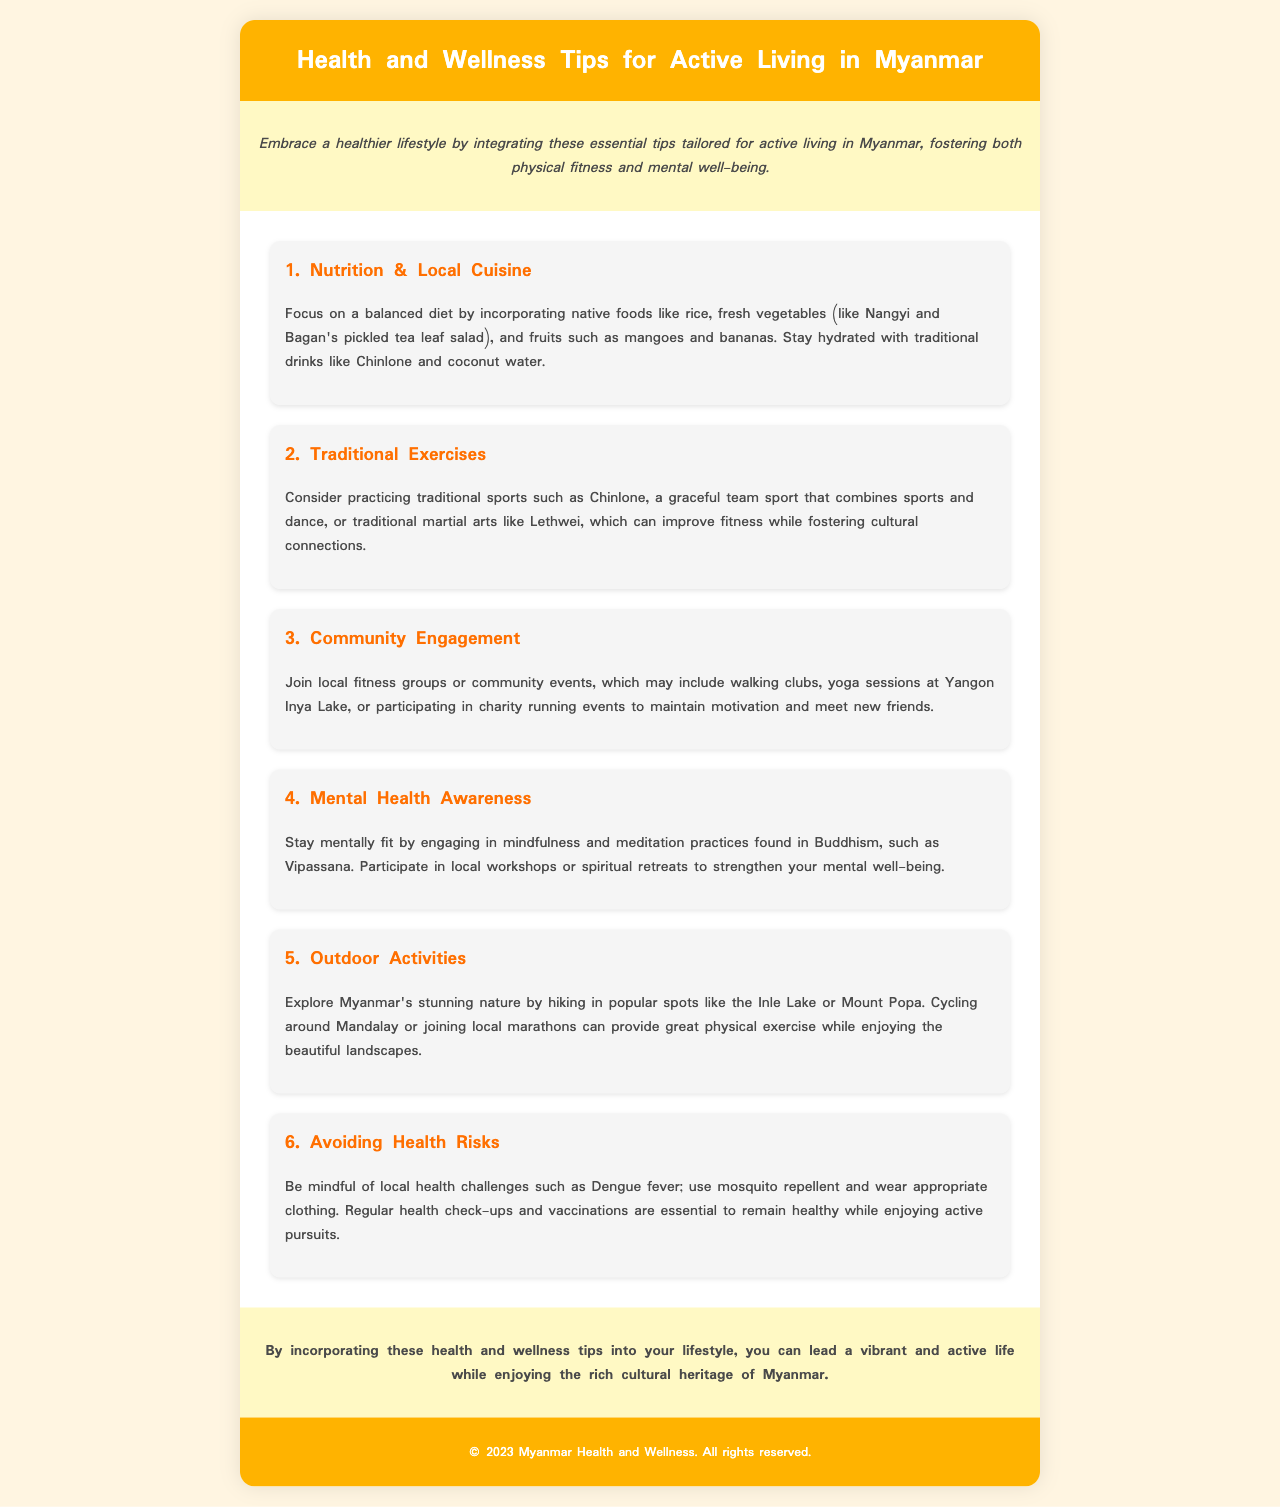What is the focus of tip 1? Tip 1 emphasizes a balanced diet incorporating native foods and hydration.
Answer: Nutrition & Local Cuisine What traditional exercise is mentioned in tip 2? Tip 2 discusses Chinlone, a traditional sport.
Answer: Chinlone Where can you participate in community fitness events according to tip 3? Tip 3 mentions local events like yoga sessions and charity runs at specific locations.
Answer: Yangon Inya Lake What is the main practice for mental health in tip 4? The document highlights mindfulness and meditation practices found in Buddhism, specifically mentioning a type of meditation.
Answer: Vipassana What should be used to avoid health risks as stated in tip 6? Tip 6 advises using a specific product to protect against local health issues.
Answer: Mosquito repellent 